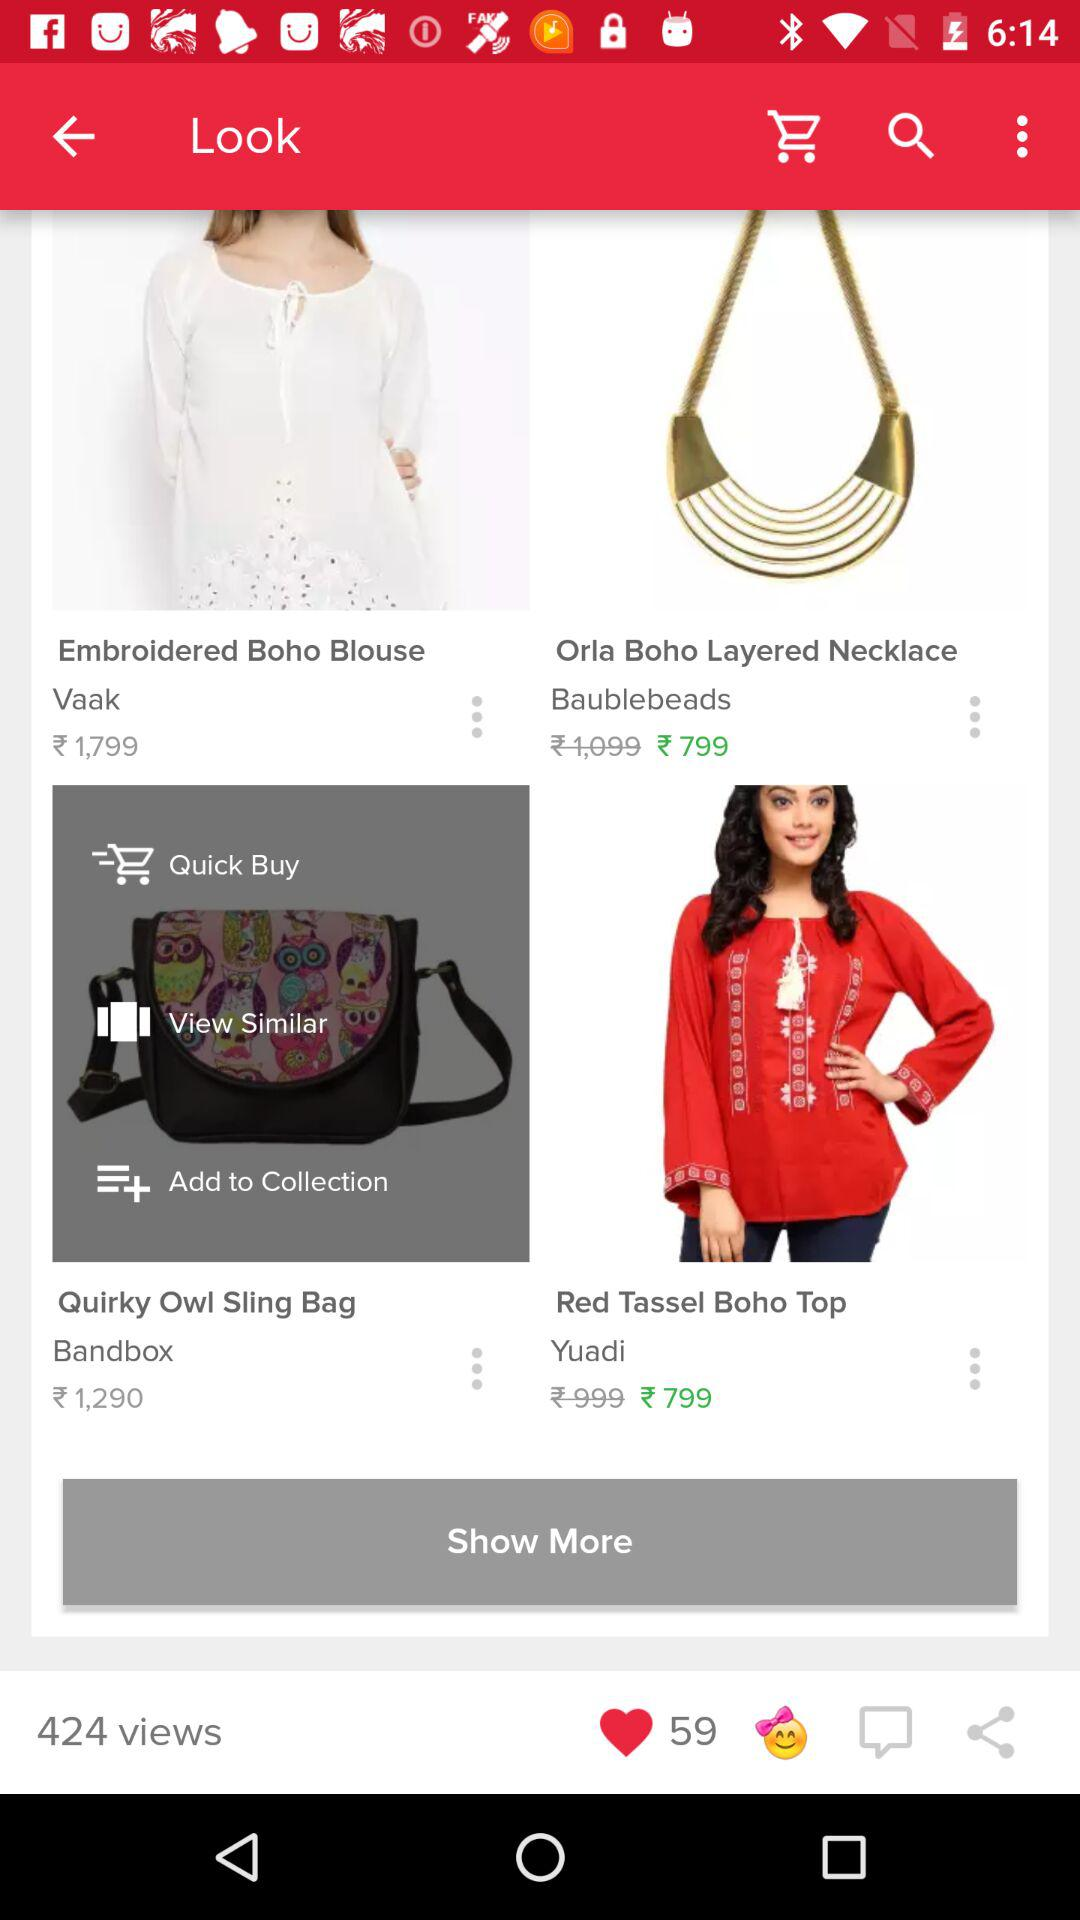How many items have a price of 1,290 or more?
Answer the question using a single word or phrase. 2 